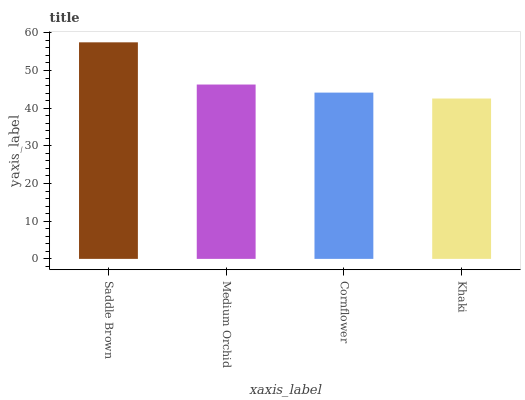Is Khaki the minimum?
Answer yes or no. Yes. Is Saddle Brown the maximum?
Answer yes or no. Yes. Is Medium Orchid the minimum?
Answer yes or no. No. Is Medium Orchid the maximum?
Answer yes or no. No. Is Saddle Brown greater than Medium Orchid?
Answer yes or no. Yes. Is Medium Orchid less than Saddle Brown?
Answer yes or no. Yes. Is Medium Orchid greater than Saddle Brown?
Answer yes or no. No. Is Saddle Brown less than Medium Orchid?
Answer yes or no. No. Is Medium Orchid the high median?
Answer yes or no. Yes. Is Cornflower the low median?
Answer yes or no. Yes. Is Khaki the high median?
Answer yes or no. No. Is Saddle Brown the low median?
Answer yes or no. No. 